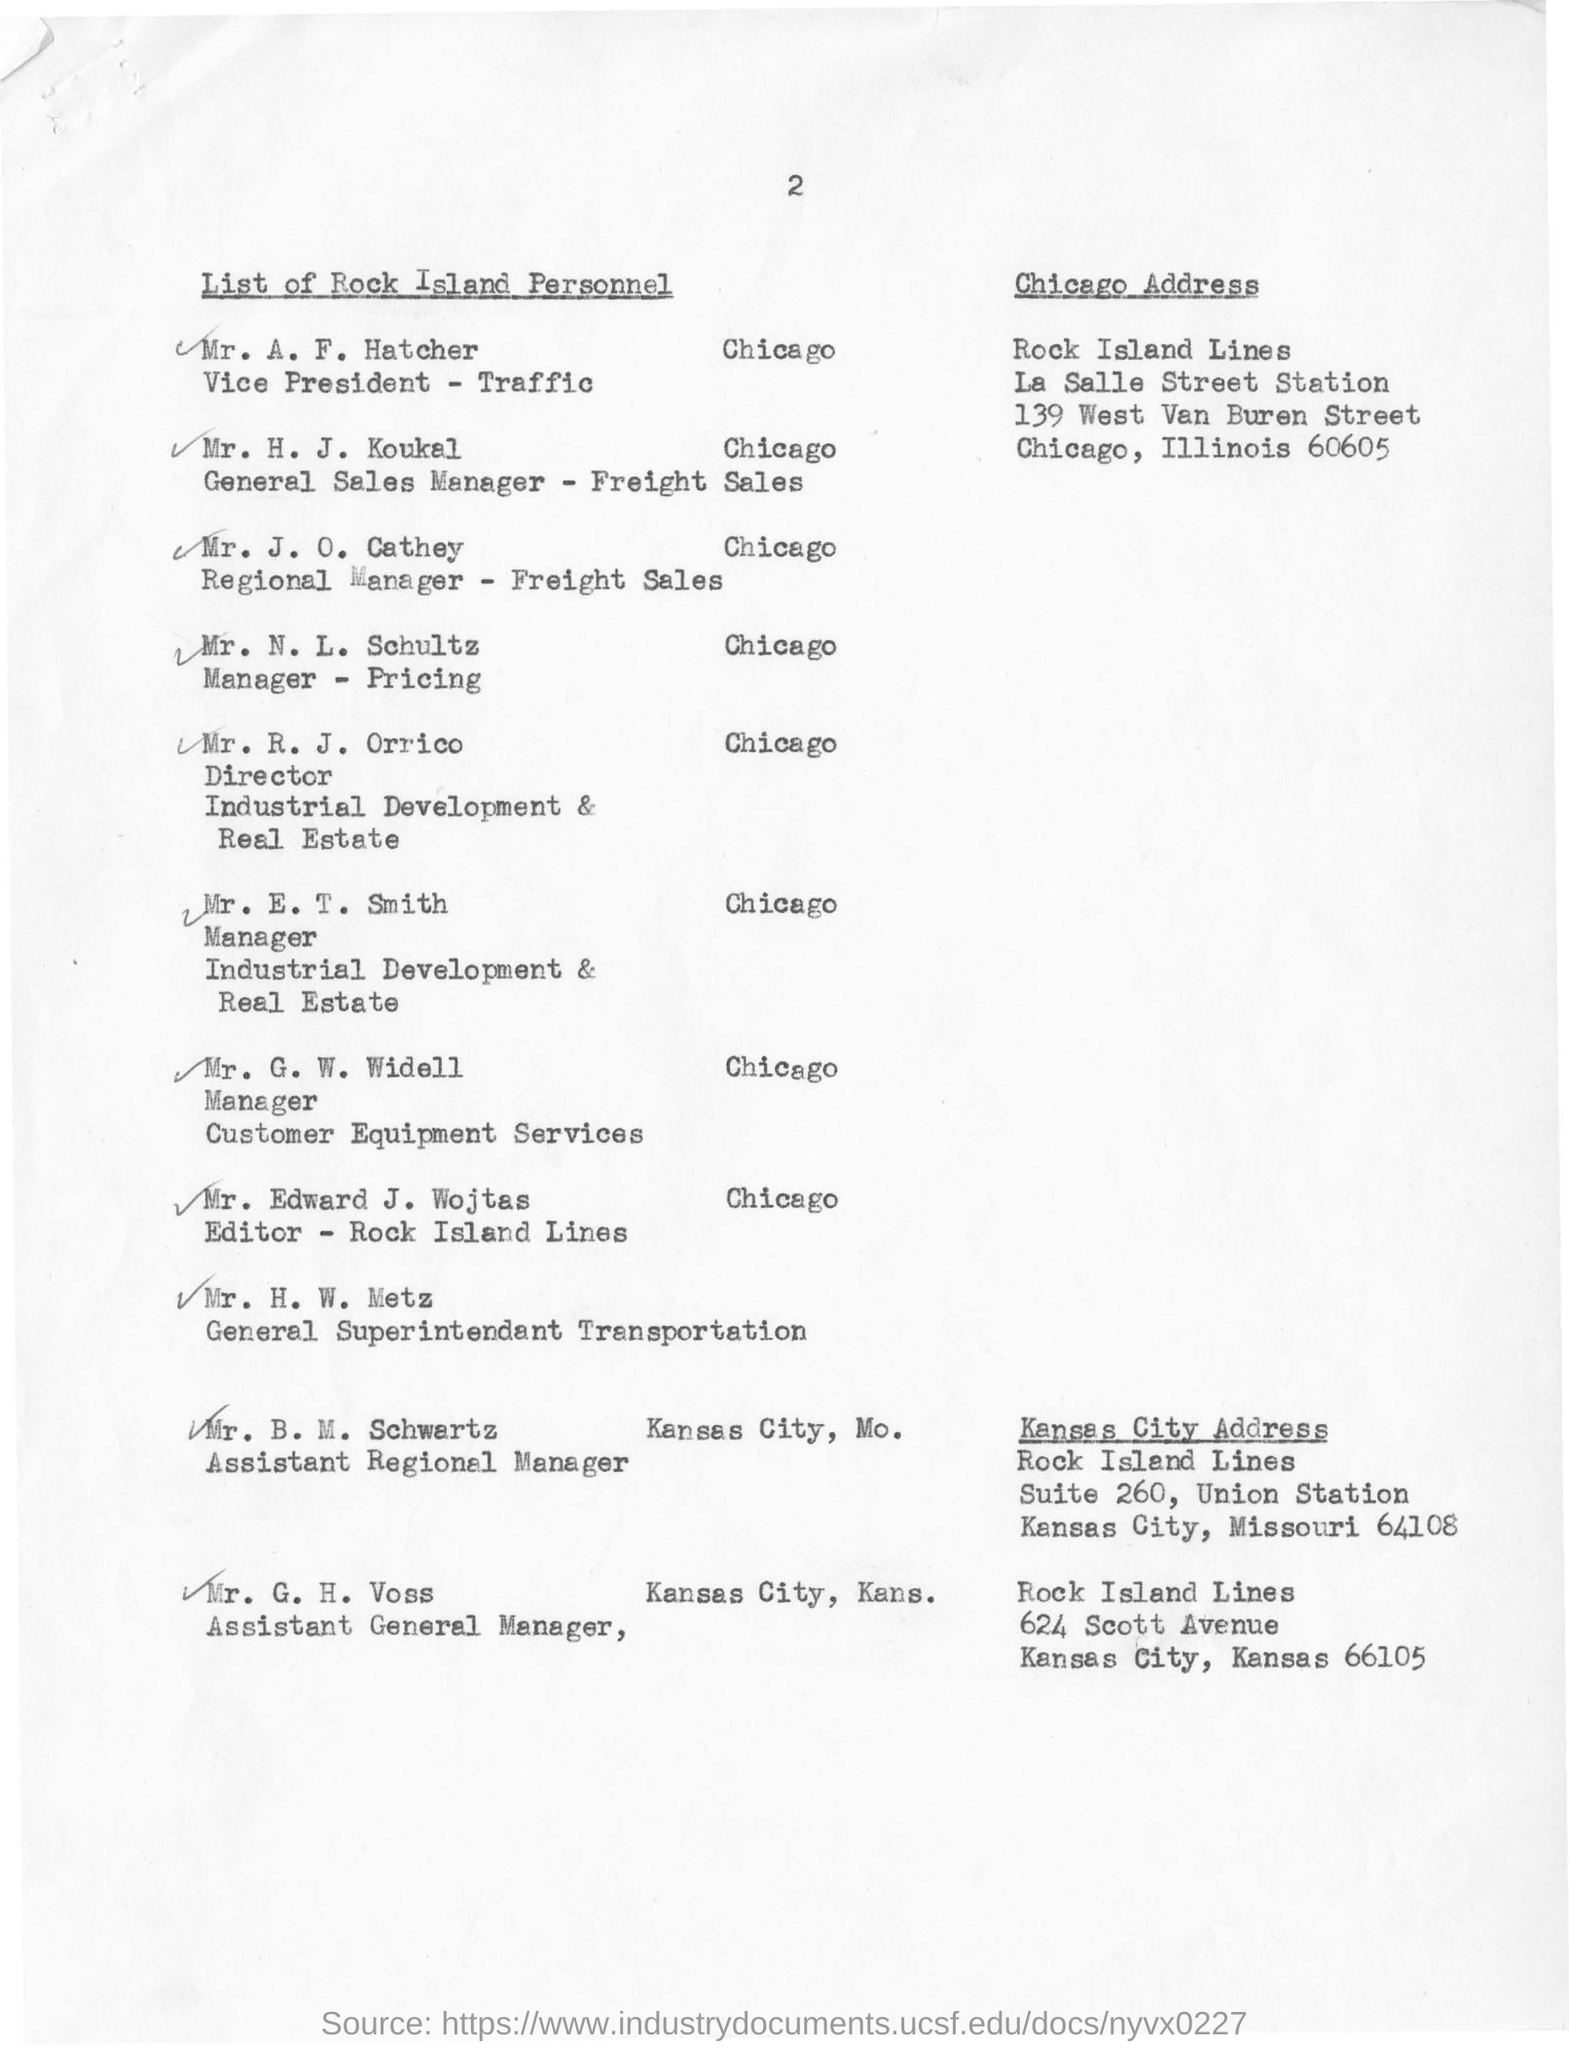Specify some key components in this picture. The individual known as Mr. N L Schultz has been designated as the Manager - Pricing. Mr. R. J. Orrico, the Director of Industrial Development & Real Estate, is responsible for overseeing the acquisition and development of industrial real estate properties for the company. Mr. H. J. Koukal has been designated as the General Sales Manager for Freight Sales. The individual known as Vice President-Traffic is named Mr. A. F. Hatcher. 